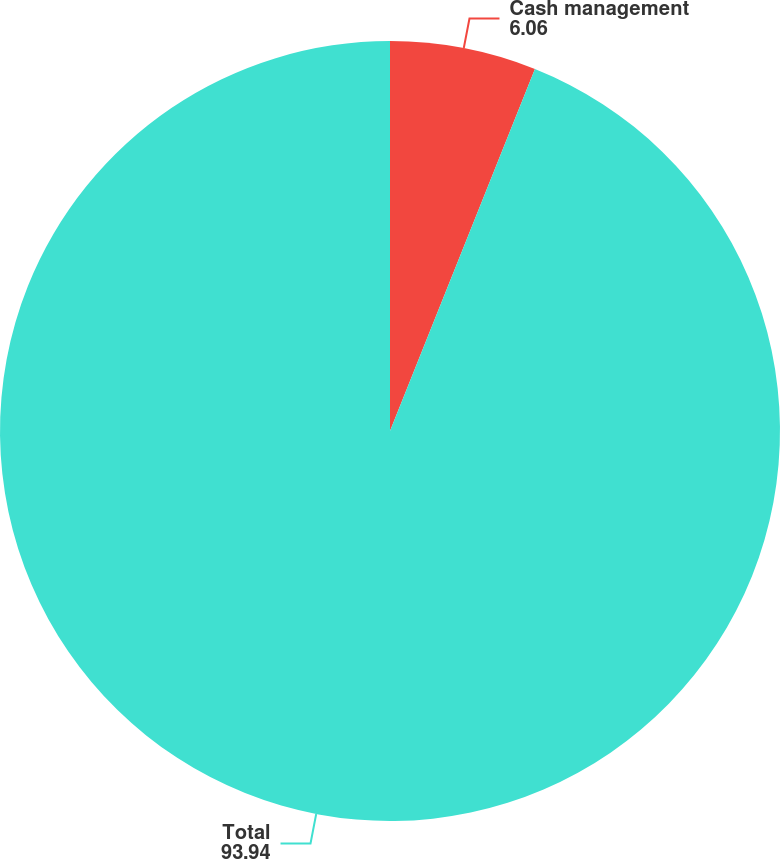Convert chart. <chart><loc_0><loc_0><loc_500><loc_500><pie_chart><fcel>Cash management<fcel>Total<nl><fcel>6.06%<fcel>93.94%<nl></chart> 